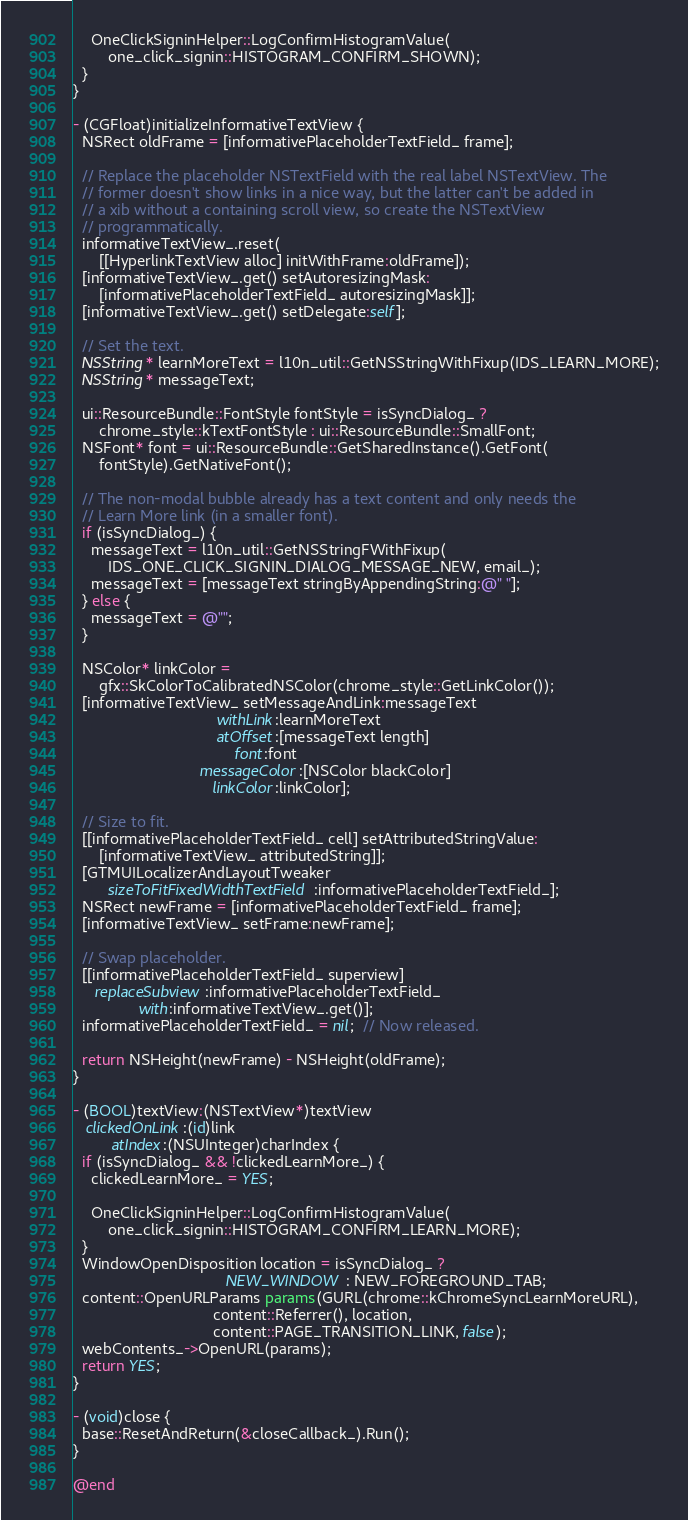<code> <loc_0><loc_0><loc_500><loc_500><_ObjectiveC_>    OneClickSigninHelper::LogConfirmHistogramValue(
        one_click_signin::HISTOGRAM_CONFIRM_SHOWN);
  }
}

- (CGFloat)initializeInformativeTextView {
  NSRect oldFrame = [informativePlaceholderTextField_ frame];

  // Replace the placeholder NSTextField with the real label NSTextView. The
  // former doesn't show links in a nice way, but the latter can't be added in
  // a xib without a containing scroll view, so create the NSTextView
  // programmatically.
  informativeTextView_.reset(
      [[HyperlinkTextView alloc] initWithFrame:oldFrame]);
  [informativeTextView_.get() setAutoresizingMask:
      [informativePlaceholderTextField_ autoresizingMask]];
  [informativeTextView_.get() setDelegate:self];

  // Set the text.
  NSString* learnMoreText = l10n_util::GetNSStringWithFixup(IDS_LEARN_MORE);
  NSString* messageText;

  ui::ResourceBundle::FontStyle fontStyle = isSyncDialog_ ?
      chrome_style::kTextFontStyle : ui::ResourceBundle::SmallFont;
  NSFont* font = ui::ResourceBundle::GetSharedInstance().GetFont(
      fontStyle).GetNativeFont();

  // The non-modal bubble already has a text content and only needs the
  // Learn More link (in a smaller font).
  if (isSyncDialog_) {
    messageText = l10n_util::GetNSStringFWithFixup(
        IDS_ONE_CLICK_SIGNIN_DIALOG_MESSAGE_NEW, email_);
    messageText = [messageText stringByAppendingString:@" "];
  } else {
    messageText = @"";
  }

  NSColor* linkColor =
      gfx::SkColorToCalibratedNSColor(chrome_style::GetLinkColor());
  [informativeTextView_ setMessageAndLink:messageText
                                 withLink:learnMoreText
                                 atOffset:[messageText length]
                                     font:font
                             messageColor:[NSColor blackColor]
                                linkColor:linkColor];

  // Size to fit.
  [[informativePlaceholderTextField_ cell] setAttributedStringValue:
      [informativeTextView_ attributedString]];
  [GTMUILocalizerAndLayoutTweaker
        sizeToFitFixedWidthTextField:informativePlaceholderTextField_];
  NSRect newFrame = [informativePlaceholderTextField_ frame];
  [informativeTextView_ setFrame:newFrame];

  // Swap placeholder.
  [[informativePlaceholderTextField_ superview]
     replaceSubview:informativePlaceholderTextField_
               with:informativeTextView_.get()];
  informativePlaceholderTextField_ = nil;  // Now released.

  return NSHeight(newFrame) - NSHeight(oldFrame);
}

- (BOOL)textView:(NSTextView*)textView
   clickedOnLink:(id)link
         atIndex:(NSUInteger)charIndex {
  if (isSyncDialog_ && !clickedLearnMore_) {
    clickedLearnMore_ = YES;

    OneClickSigninHelper::LogConfirmHistogramValue(
        one_click_signin::HISTOGRAM_CONFIRM_LEARN_MORE);
  }
  WindowOpenDisposition location = isSyncDialog_ ?
                                   NEW_WINDOW : NEW_FOREGROUND_TAB;
  content::OpenURLParams params(GURL(chrome::kChromeSyncLearnMoreURL),
                                content::Referrer(), location,
                                content::PAGE_TRANSITION_LINK, false);
  webContents_->OpenURL(params);
  return YES;
}

- (void)close {
  base::ResetAndReturn(&closeCallback_).Run();
}

@end
</code> 